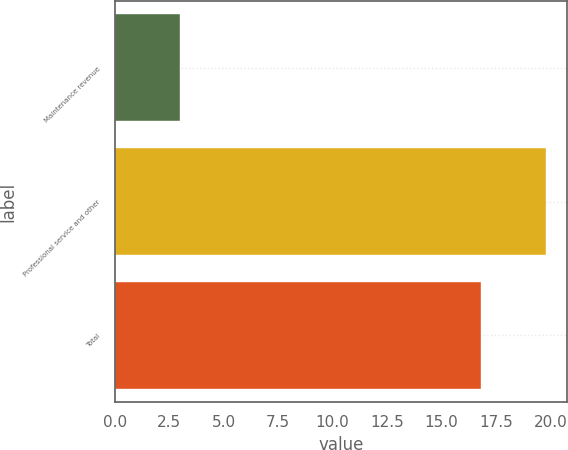Convert chart to OTSL. <chart><loc_0><loc_0><loc_500><loc_500><bar_chart><fcel>Maintenance revenue<fcel>Professional service and other<fcel>Total<nl><fcel>3<fcel>19.8<fcel>16.8<nl></chart> 